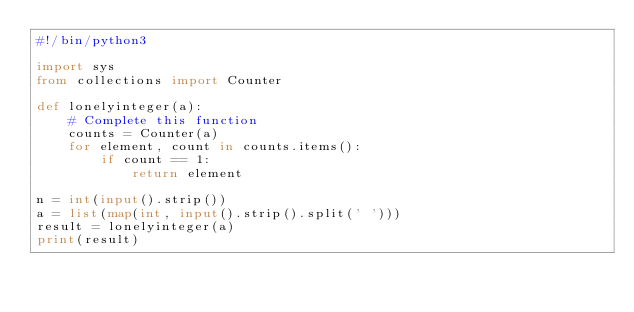Convert code to text. <code><loc_0><loc_0><loc_500><loc_500><_Python_>#!/bin/python3

import sys
from collections import Counter

def lonelyinteger(a):
    # Complete this function
    counts = Counter(a)
    for element, count in counts.items():
        if count == 1:
            return element

n = int(input().strip())
a = list(map(int, input().strip().split(' ')))
result = lonelyinteger(a)
print(result)
</code> 